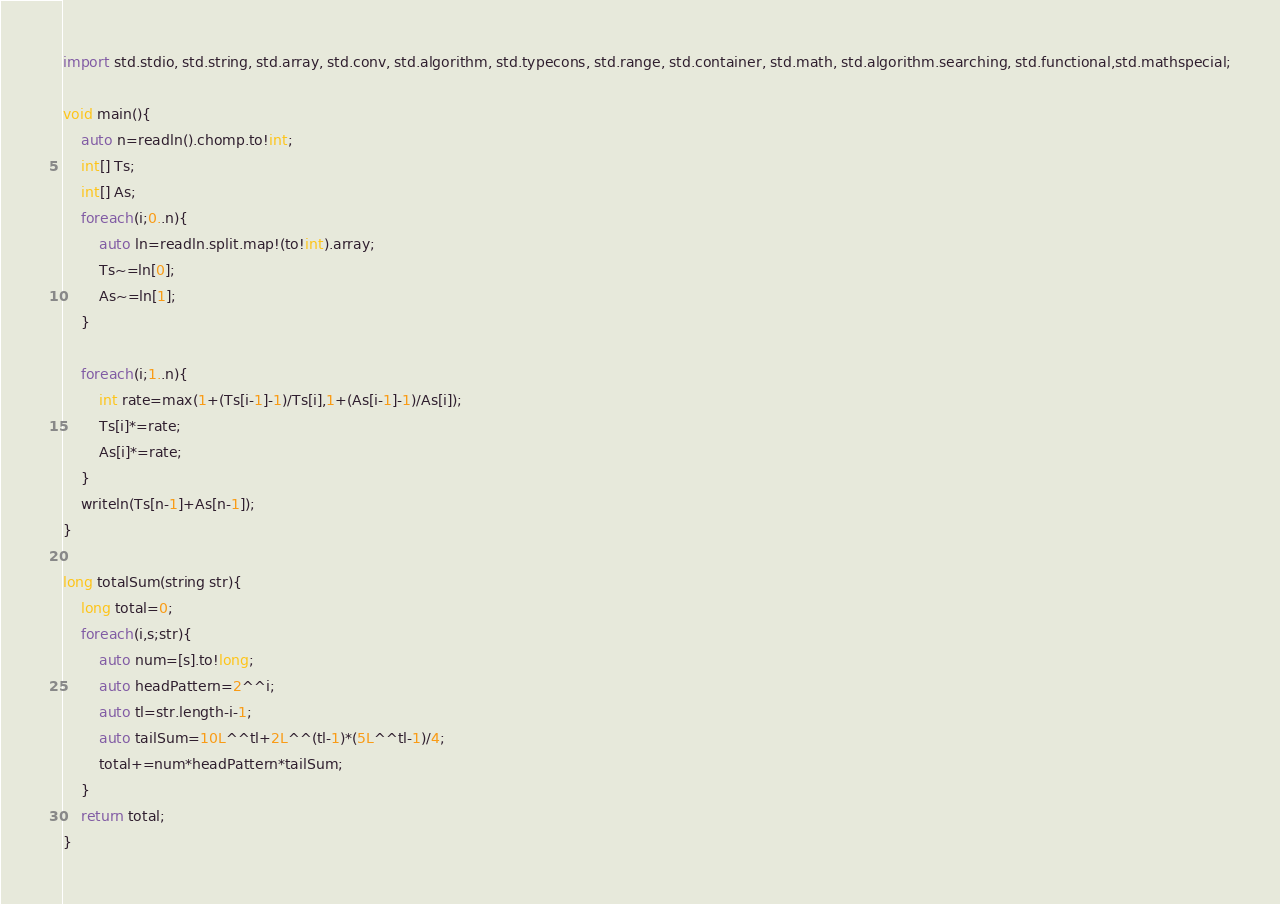<code> <loc_0><loc_0><loc_500><loc_500><_D_>import std.stdio, std.string, std.array, std.conv, std.algorithm, std.typecons, std.range, std.container, std.math, std.algorithm.searching, std.functional,std.mathspecial;

void main(){
    auto n=readln().chomp.to!int;
    int[] Ts;
    int[] As;
    foreach(i;0..n){
        auto ln=readln.split.map!(to!int).array;
        Ts~=ln[0];
        As~=ln[1];
    }

    foreach(i;1..n){
        int rate=max(1+(Ts[i-1]-1)/Ts[i],1+(As[i-1]-1)/As[i]);
        Ts[i]*=rate;
        As[i]*=rate;
    }
    writeln(Ts[n-1]+As[n-1]);
}

long totalSum(string str){
    long total=0;
    foreach(i,s;str){
        auto num=[s].to!long;
        auto headPattern=2^^i;
        auto tl=str.length-i-1;
        auto tailSum=10L^^tl+2L^^(tl-1)*(5L^^tl-1)/4;
        total+=num*headPattern*tailSum;
    }
    return total;
}</code> 